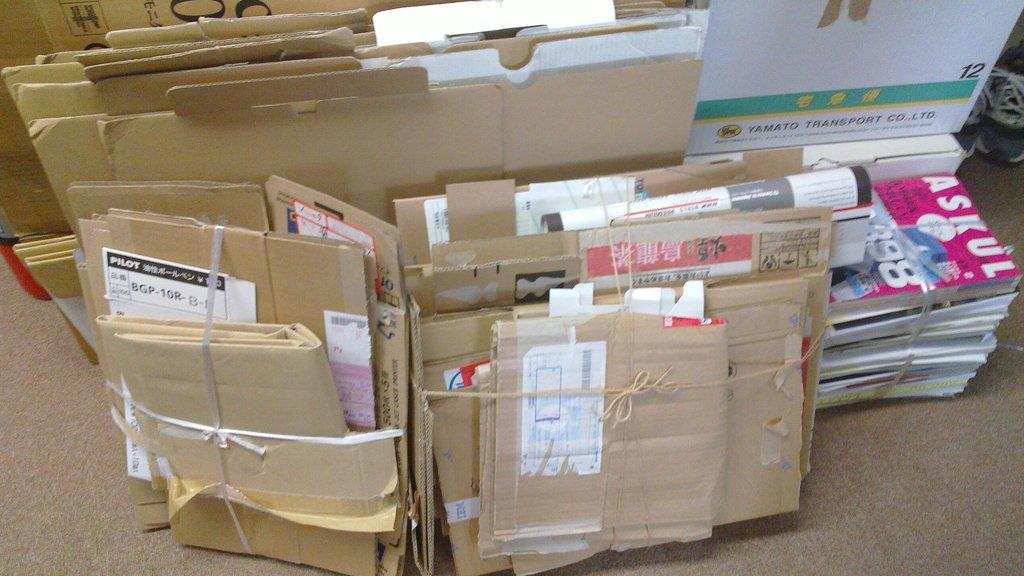<image>
Render a clear and concise summary of the photo. Bundles of mail and booklets with a brown cardboard that says "PILOT". 